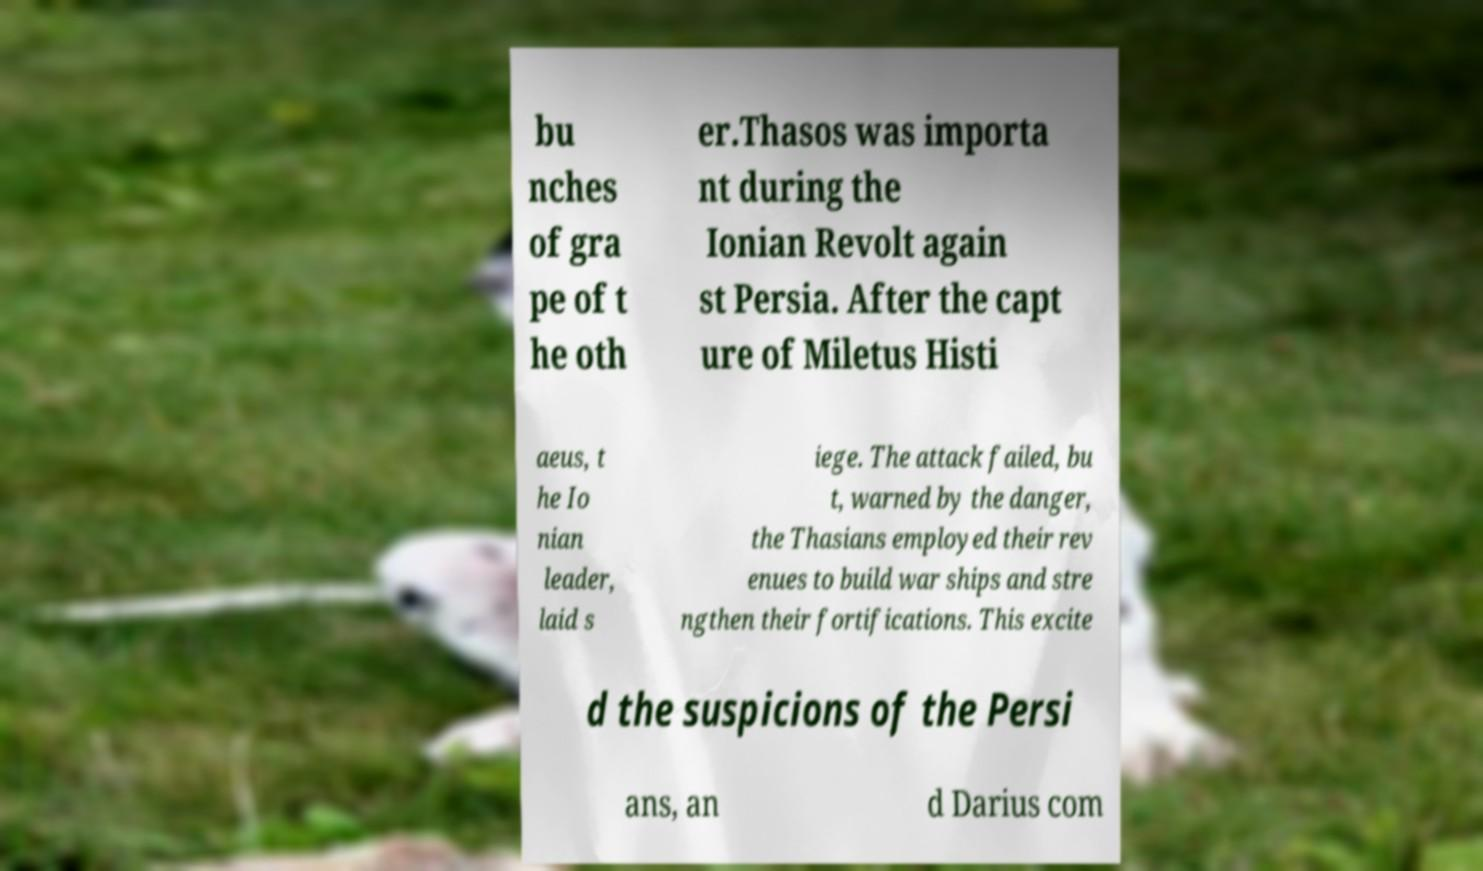There's text embedded in this image that I need extracted. Can you transcribe it verbatim? bu nches of gra pe of t he oth er.Thasos was importa nt during the Ionian Revolt again st Persia. After the capt ure of Miletus Histi aeus, t he Io nian leader, laid s iege. The attack failed, bu t, warned by the danger, the Thasians employed their rev enues to build war ships and stre ngthen their fortifications. This excite d the suspicions of the Persi ans, an d Darius com 